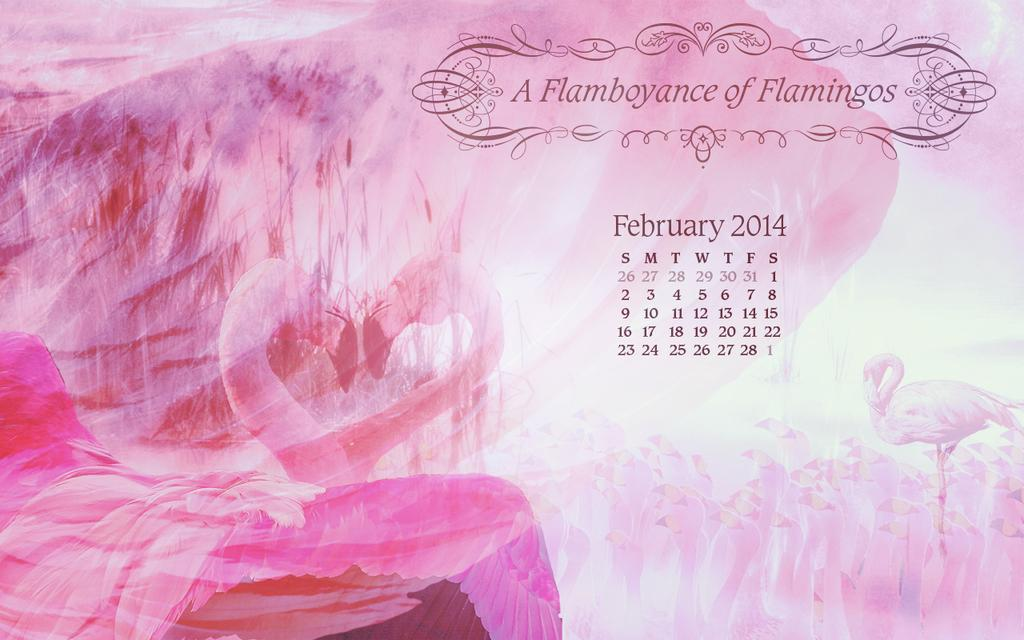What is featured in the image? There is a poster in the image. What can be found on the poster? The poster contains text and a calendar. How many screws are visible on the poster in the image? There are no screws visible on the poster in the image. What type of frogs are depicted on the poster? There are no frogs present on the poster in the image. 